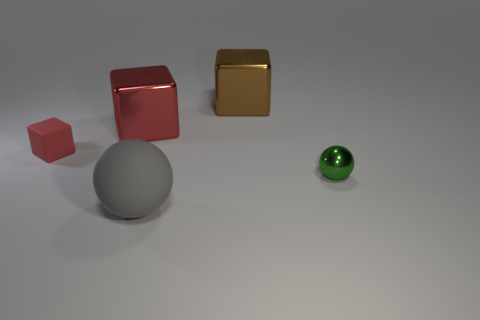Add 1 tiny cylinders. How many objects exist? 6 Subtract all large metal cubes. How many cubes are left? 1 Subtract all gray cubes. How many blue balls are left? 0 Subtract all large gray things. Subtract all big brown metallic things. How many objects are left? 3 Add 1 big brown blocks. How many big brown blocks are left? 2 Add 3 matte blocks. How many matte blocks exist? 4 Subtract all red blocks. How many blocks are left? 1 Subtract 0 brown balls. How many objects are left? 5 Subtract all cubes. How many objects are left? 2 Subtract 2 balls. How many balls are left? 0 